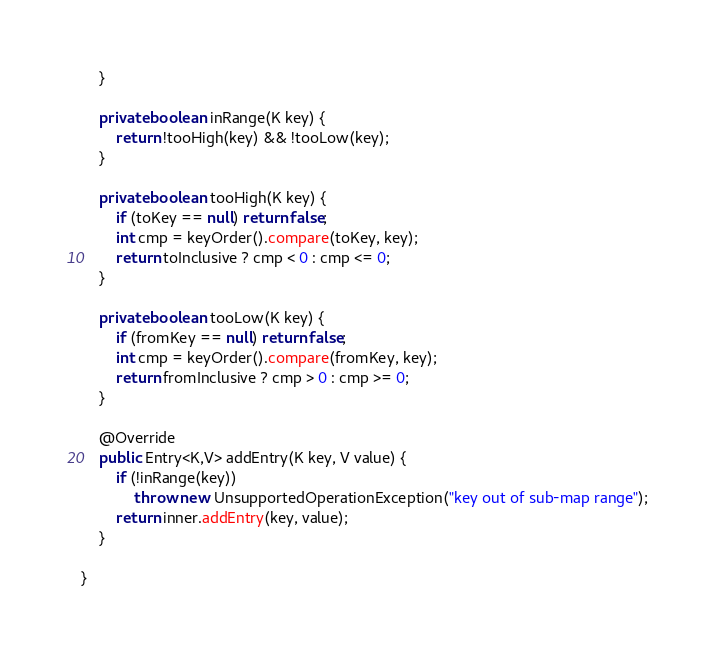Convert code to text. <code><loc_0><loc_0><loc_500><loc_500><_Java_>    }

    private boolean inRange(K key) {
        return !tooHigh(key) && !tooLow(key);
    }

    private boolean tooHigh(K key) {
        if (toKey == null) return false;
        int cmp = keyOrder().compare(toKey, key);
        return toInclusive ? cmp < 0 : cmp <= 0;
    }

    private boolean tooLow(K key) {
        if (fromKey == null) return false;
        int cmp = keyOrder().compare(fromKey, key);
        return fromInclusive ? cmp > 0 : cmp >= 0;
    }

    @Override
    public Entry<K,V> addEntry(K key, V value) {
        if (!inRange(key)) 
            throw new UnsupportedOperationException("key out of sub-map range");
        return inner.addEntry(key, value);
    }
    
}
</code> 